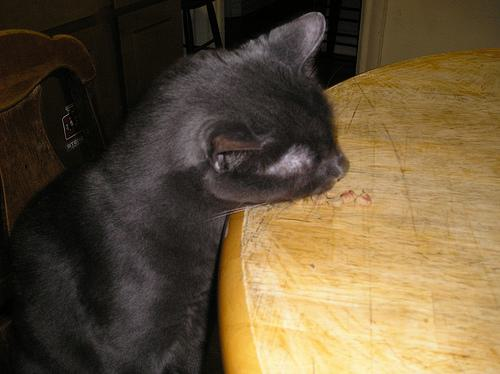Is there a dining table in the image? No, the image does not show a dining table; it features a grey cat sitting near a small wooden table, which does not have the characteristics of a dining table. 